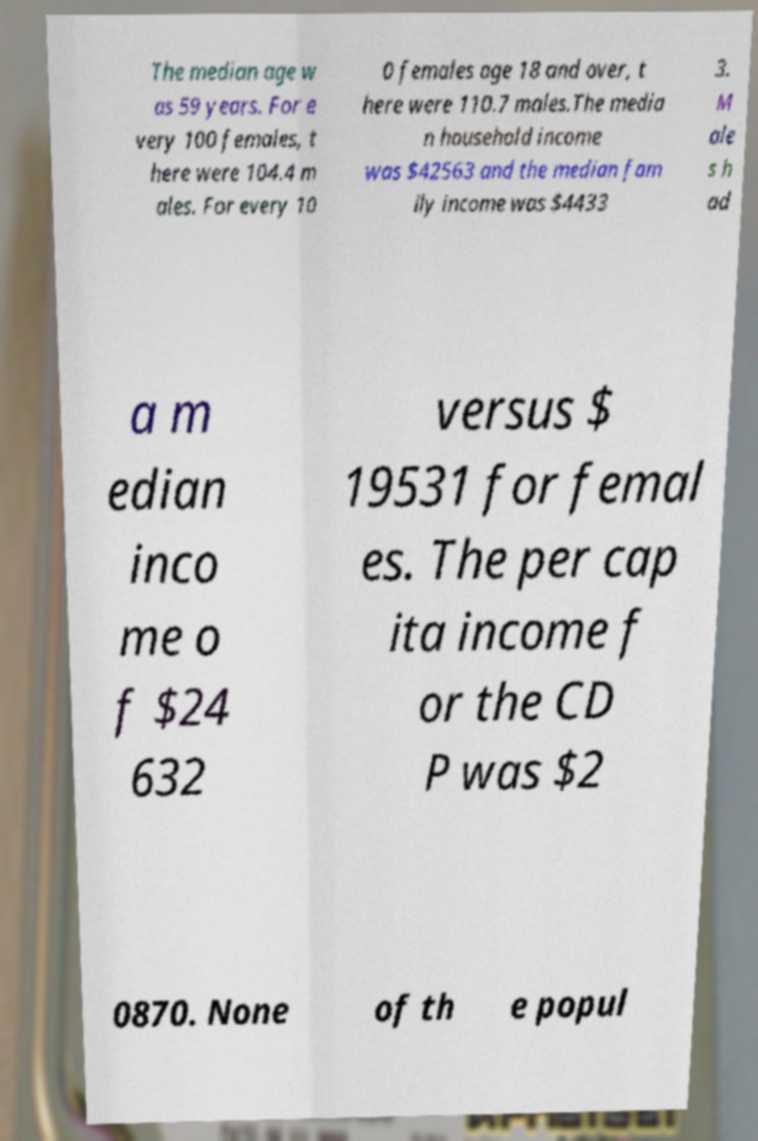Can you accurately transcribe the text from the provided image for me? The median age w as 59 years. For e very 100 females, t here were 104.4 m ales. For every 10 0 females age 18 and over, t here were 110.7 males.The media n household income was $42563 and the median fam ily income was $4433 3. M ale s h ad a m edian inco me o f $24 632 versus $ 19531 for femal es. The per cap ita income f or the CD P was $2 0870. None of th e popul 